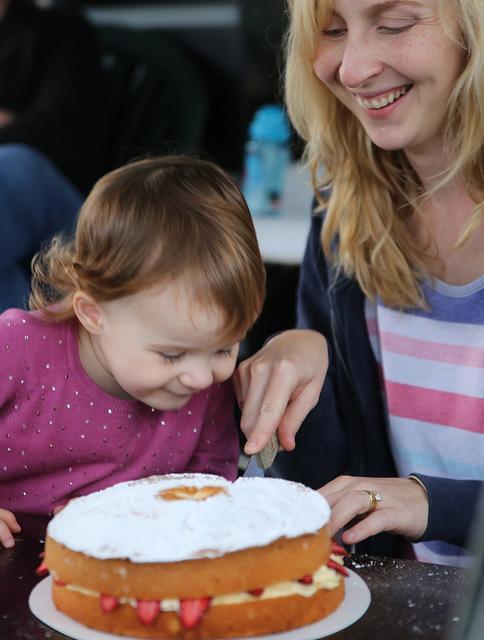How many people are visible?
Give a very brief answer. 3. 